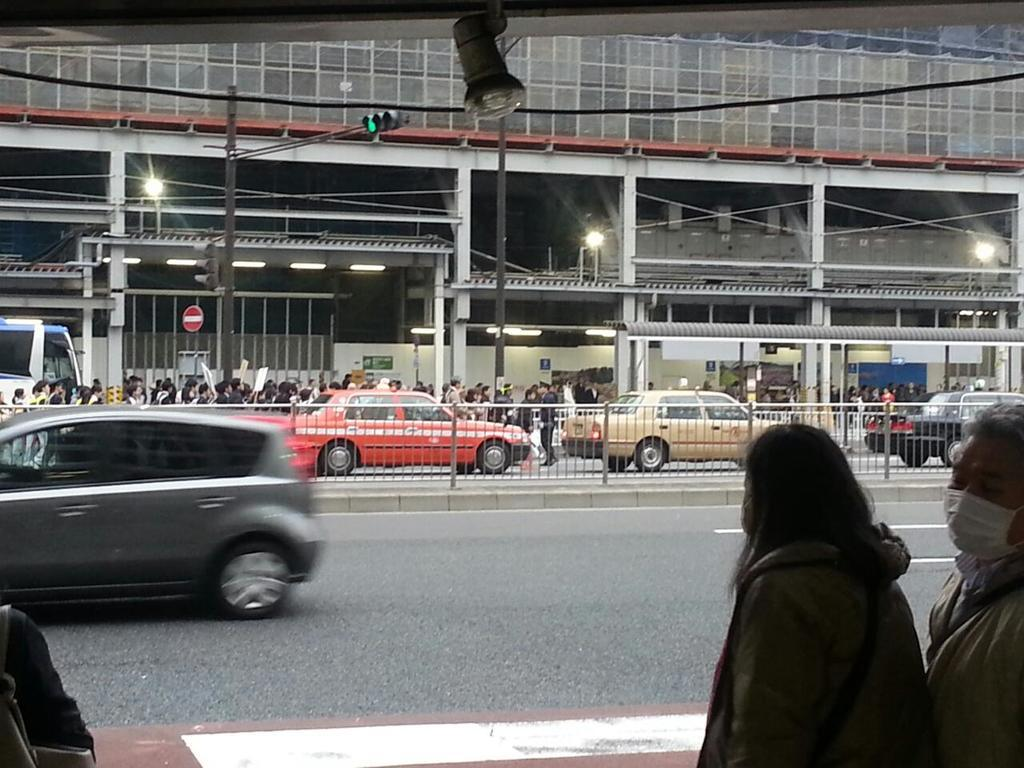Who or what can be seen in the image? There are people in the image. What else is present in the image besides people? There are vehicles on the road in the image. What can be seen in the distance or background of the image? There are lights visible in the background of the image. What type of art can be seen on the island in the image? There is no island present in the image, and therefore no art on an island can be observed. 